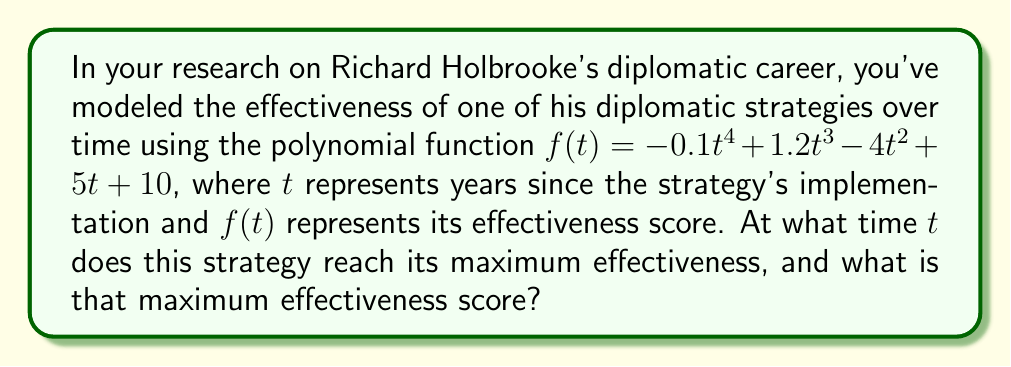Provide a solution to this math problem. To find the maximum effectiveness of the diplomatic strategy, we need to follow these steps:

1) First, we need to find the derivative of the function $f(t)$:
   $$f'(t) = -0.4t^3 + 3.6t^2 - 8t + 5$$

2) To find the critical points, we set $f'(t) = 0$ and solve for $t$:
   $$-0.4t^3 + 3.6t^2 - 8t + 5 = 0$$

3) This is a cubic equation. While it can be solved algebraically, it's complex. Using a numerical method or graphing calculator, we find the roots are approximately:
   $t ≈ 0.7858$, $t ≈ 3.3485$, and $t ≈ 5.8657$

4) To determine which of these critical points gives the maximum, we can use the second derivative test:
   $$f''(t) = -1.2t^2 + 7.2t - 8$$

5) Evaluating $f''(t)$ at each critical point:
   $f''(0.7858) ≈ 2.3636$ (positive, local minimum)
   $f''(3.3485) ≈ -2.3636$ (negative, local maximum)
   $f''(5.8657) ≈ 2.3636$ (positive, local minimum)

6) The maximum occurs at $t ≈ 3.3485$ years.

7) To find the maximum effectiveness score, we substitute this $t$ value back into the original function:
   $$f(3.3485) ≈ -0.1(3.3485)^4 + 1.2(3.3485)^3 - 4(3.3485)^2 + 5(3.3485) + 10 ≈ 14.0718$$
Answer: The diplomatic strategy reaches its maximum effectiveness after approximately 3.3485 years, with a maximum effectiveness score of approximately 14.0718. 